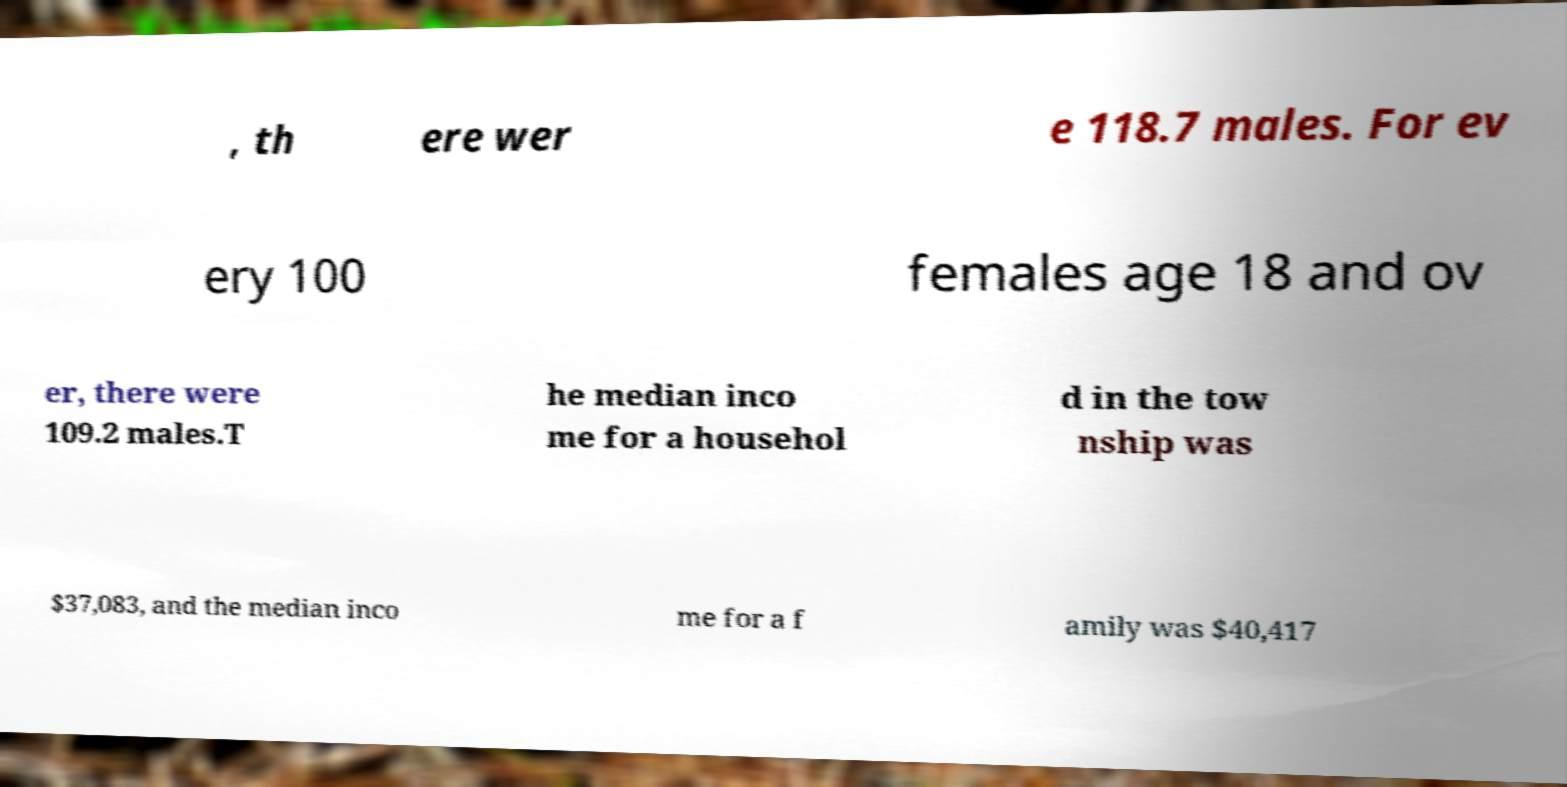Please read and relay the text visible in this image. What does it say? , th ere wer e 118.7 males. For ev ery 100 females age 18 and ov er, there were 109.2 males.T he median inco me for a househol d in the tow nship was $37,083, and the median inco me for a f amily was $40,417 